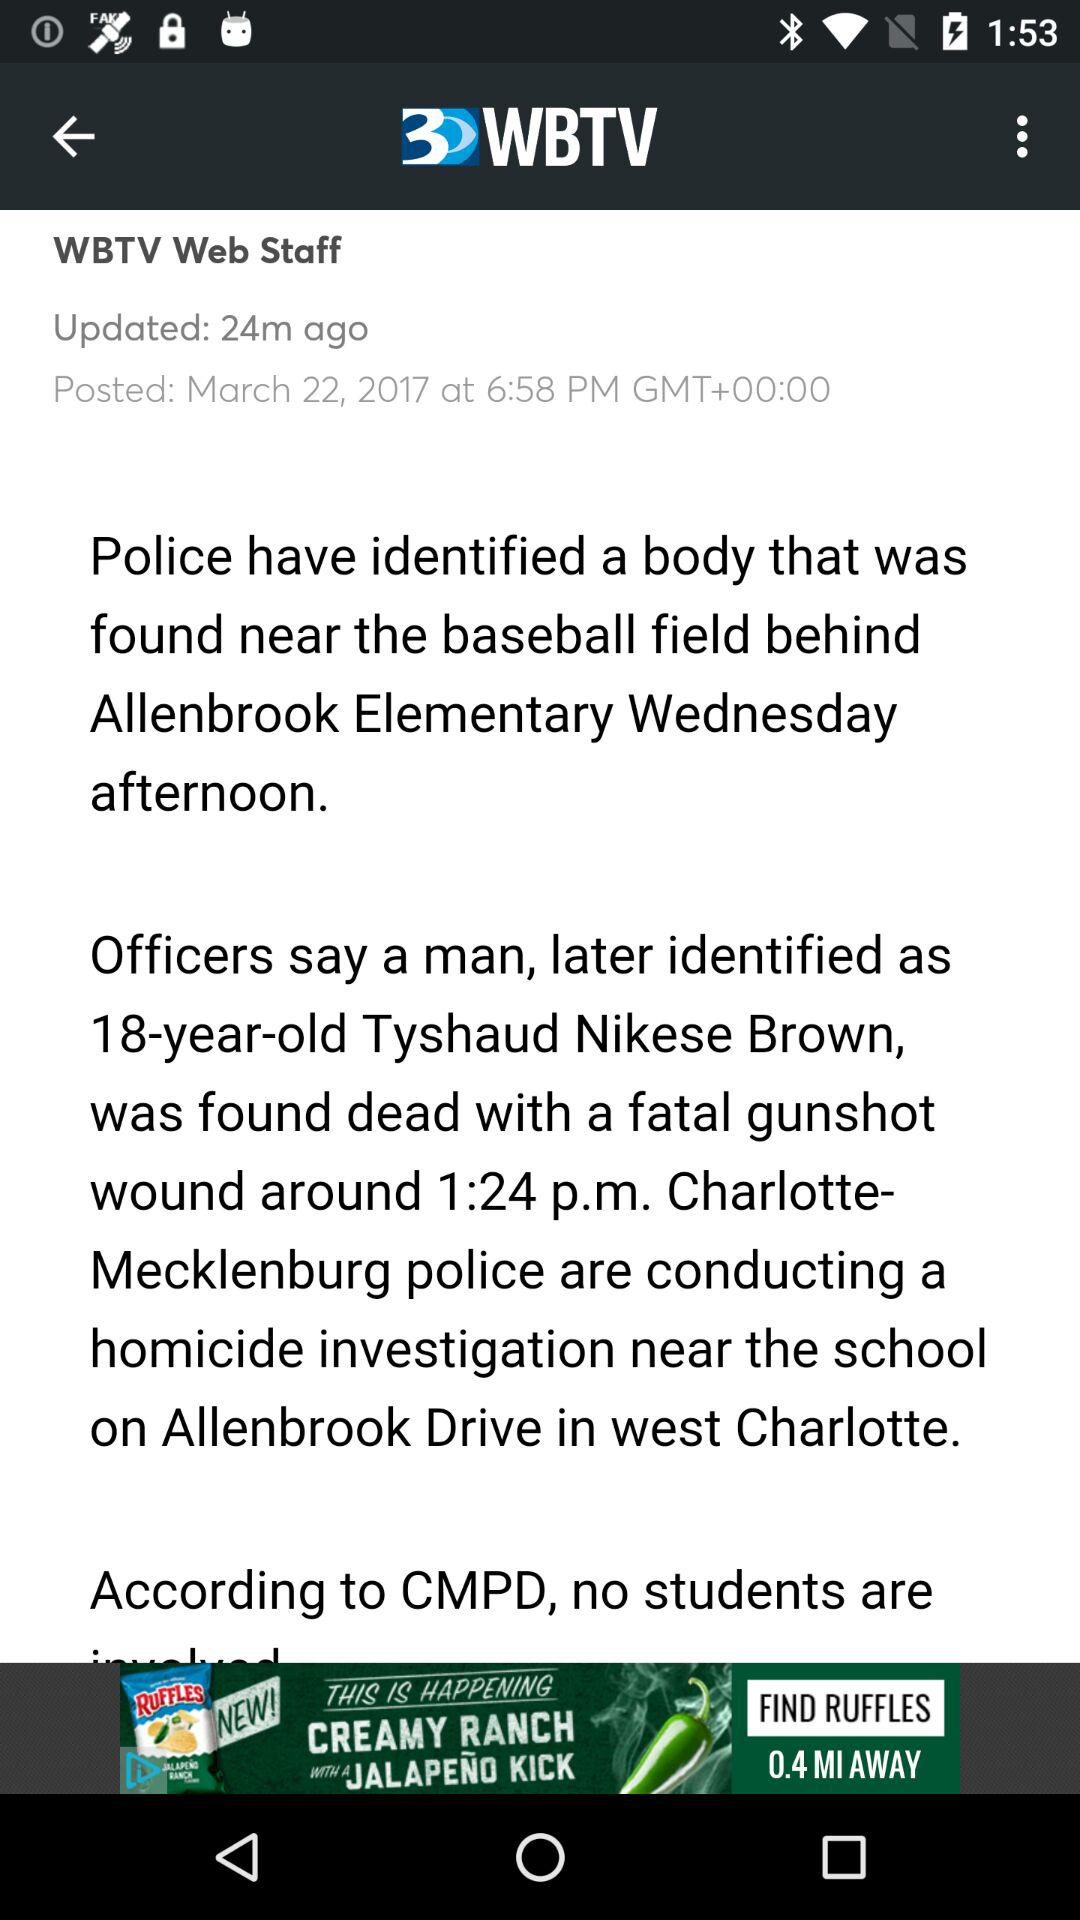What is the age of Tyshaud Nikese Brown? Tyshaud Nikese Brown is 18 years old. 